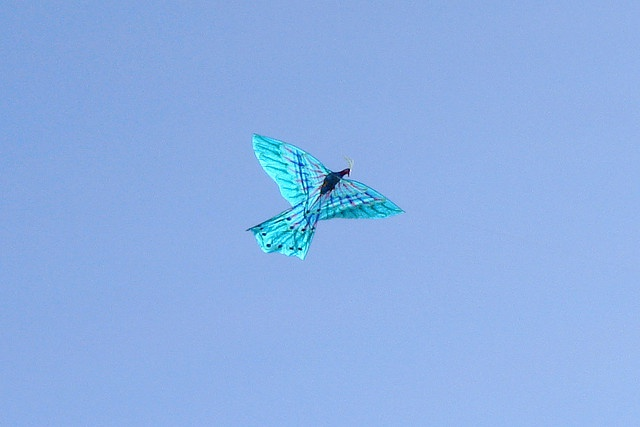Describe the objects in this image and their specific colors. I can see a kite in lightblue, cyan, and teal tones in this image. 